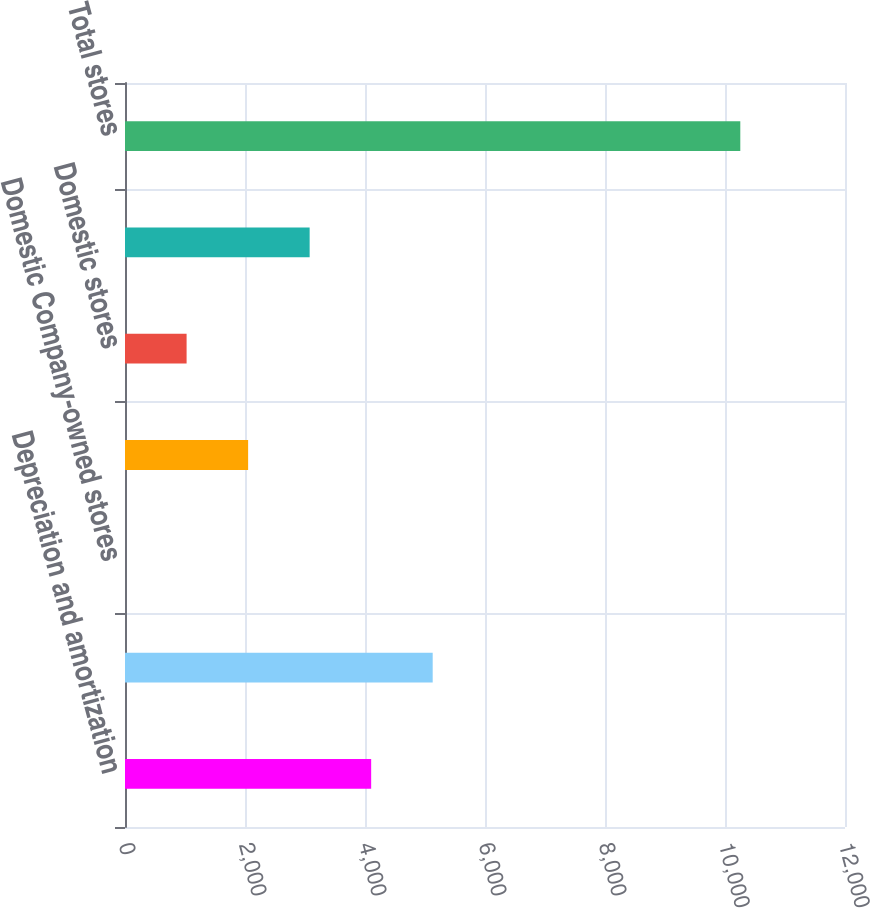Convert chart to OTSL. <chart><loc_0><loc_0><loc_500><loc_500><bar_chart><fcel>Depreciation and amortization<fcel>Capital expenditures<fcel>Domestic Company-owned stores<fcel>Domestic franchise stores<fcel>Domestic stores<fcel>International stores<fcel>Total stores<nl><fcel>4102.78<fcel>5128.15<fcel>1.3<fcel>2052.04<fcel>1026.67<fcel>3077.41<fcel>10255<nl></chart> 